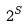<formula> <loc_0><loc_0><loc_500><loc_500>2 ^ { S }</formula> 